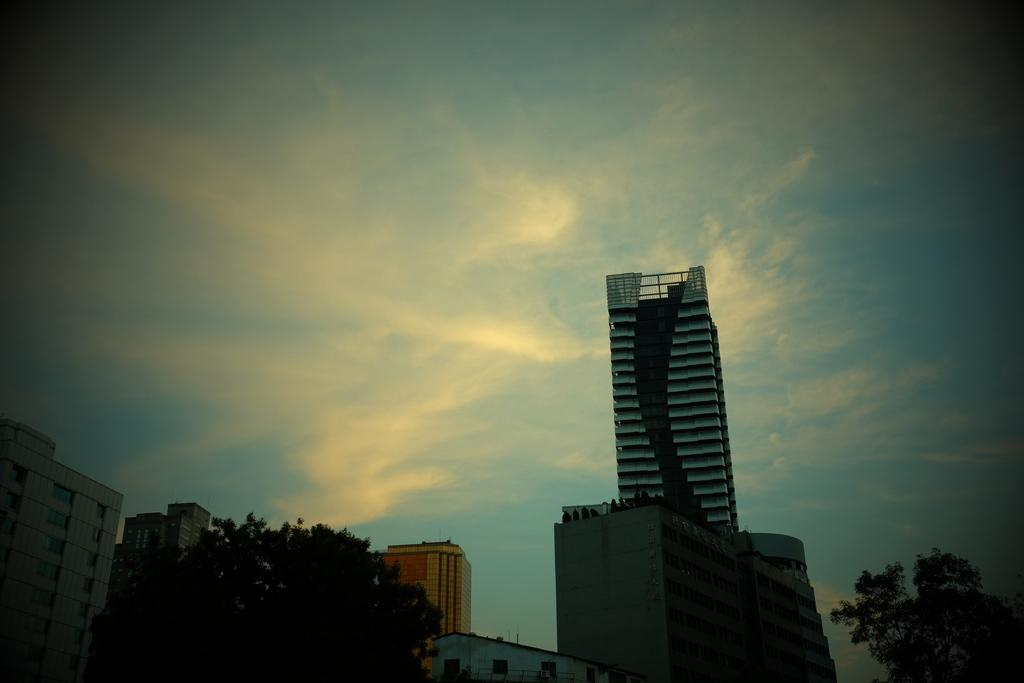What type of structures are located at the bottom side of the image? There are buildings at the bottom side of the image. What type of vegetation can be seen on the right side of the image? There are trees on the right side of the image. What type of vegetation can be seen on the left side of the image? There are trees on the left side of the image. What is visible at the top side of the image? There is sky at the top side of the image. Can you tell me how many writers are present in the image? There is no writer present in the image; it features buildings, trees, and sky. Is there a shop visible in the image? There is no shop visible in the image; it features buildings, trees, and sky. 